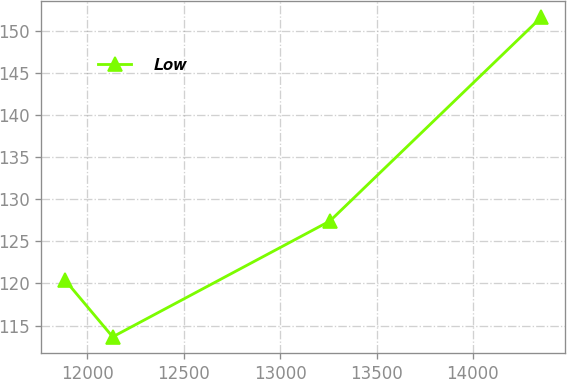Convert chart to OTSL. <chart><loc_0><loc_0><loc_500><loc_500><line_chart><ecel><fcel>Low<nl><fcel>11883.7<fcel>120.39<nl><fcel>12130.7<fcel>113.65<nl><fcel>13258.1<fcel>127.42<nl><fcel>14354.2<fcel>151.62<nl></chart> 